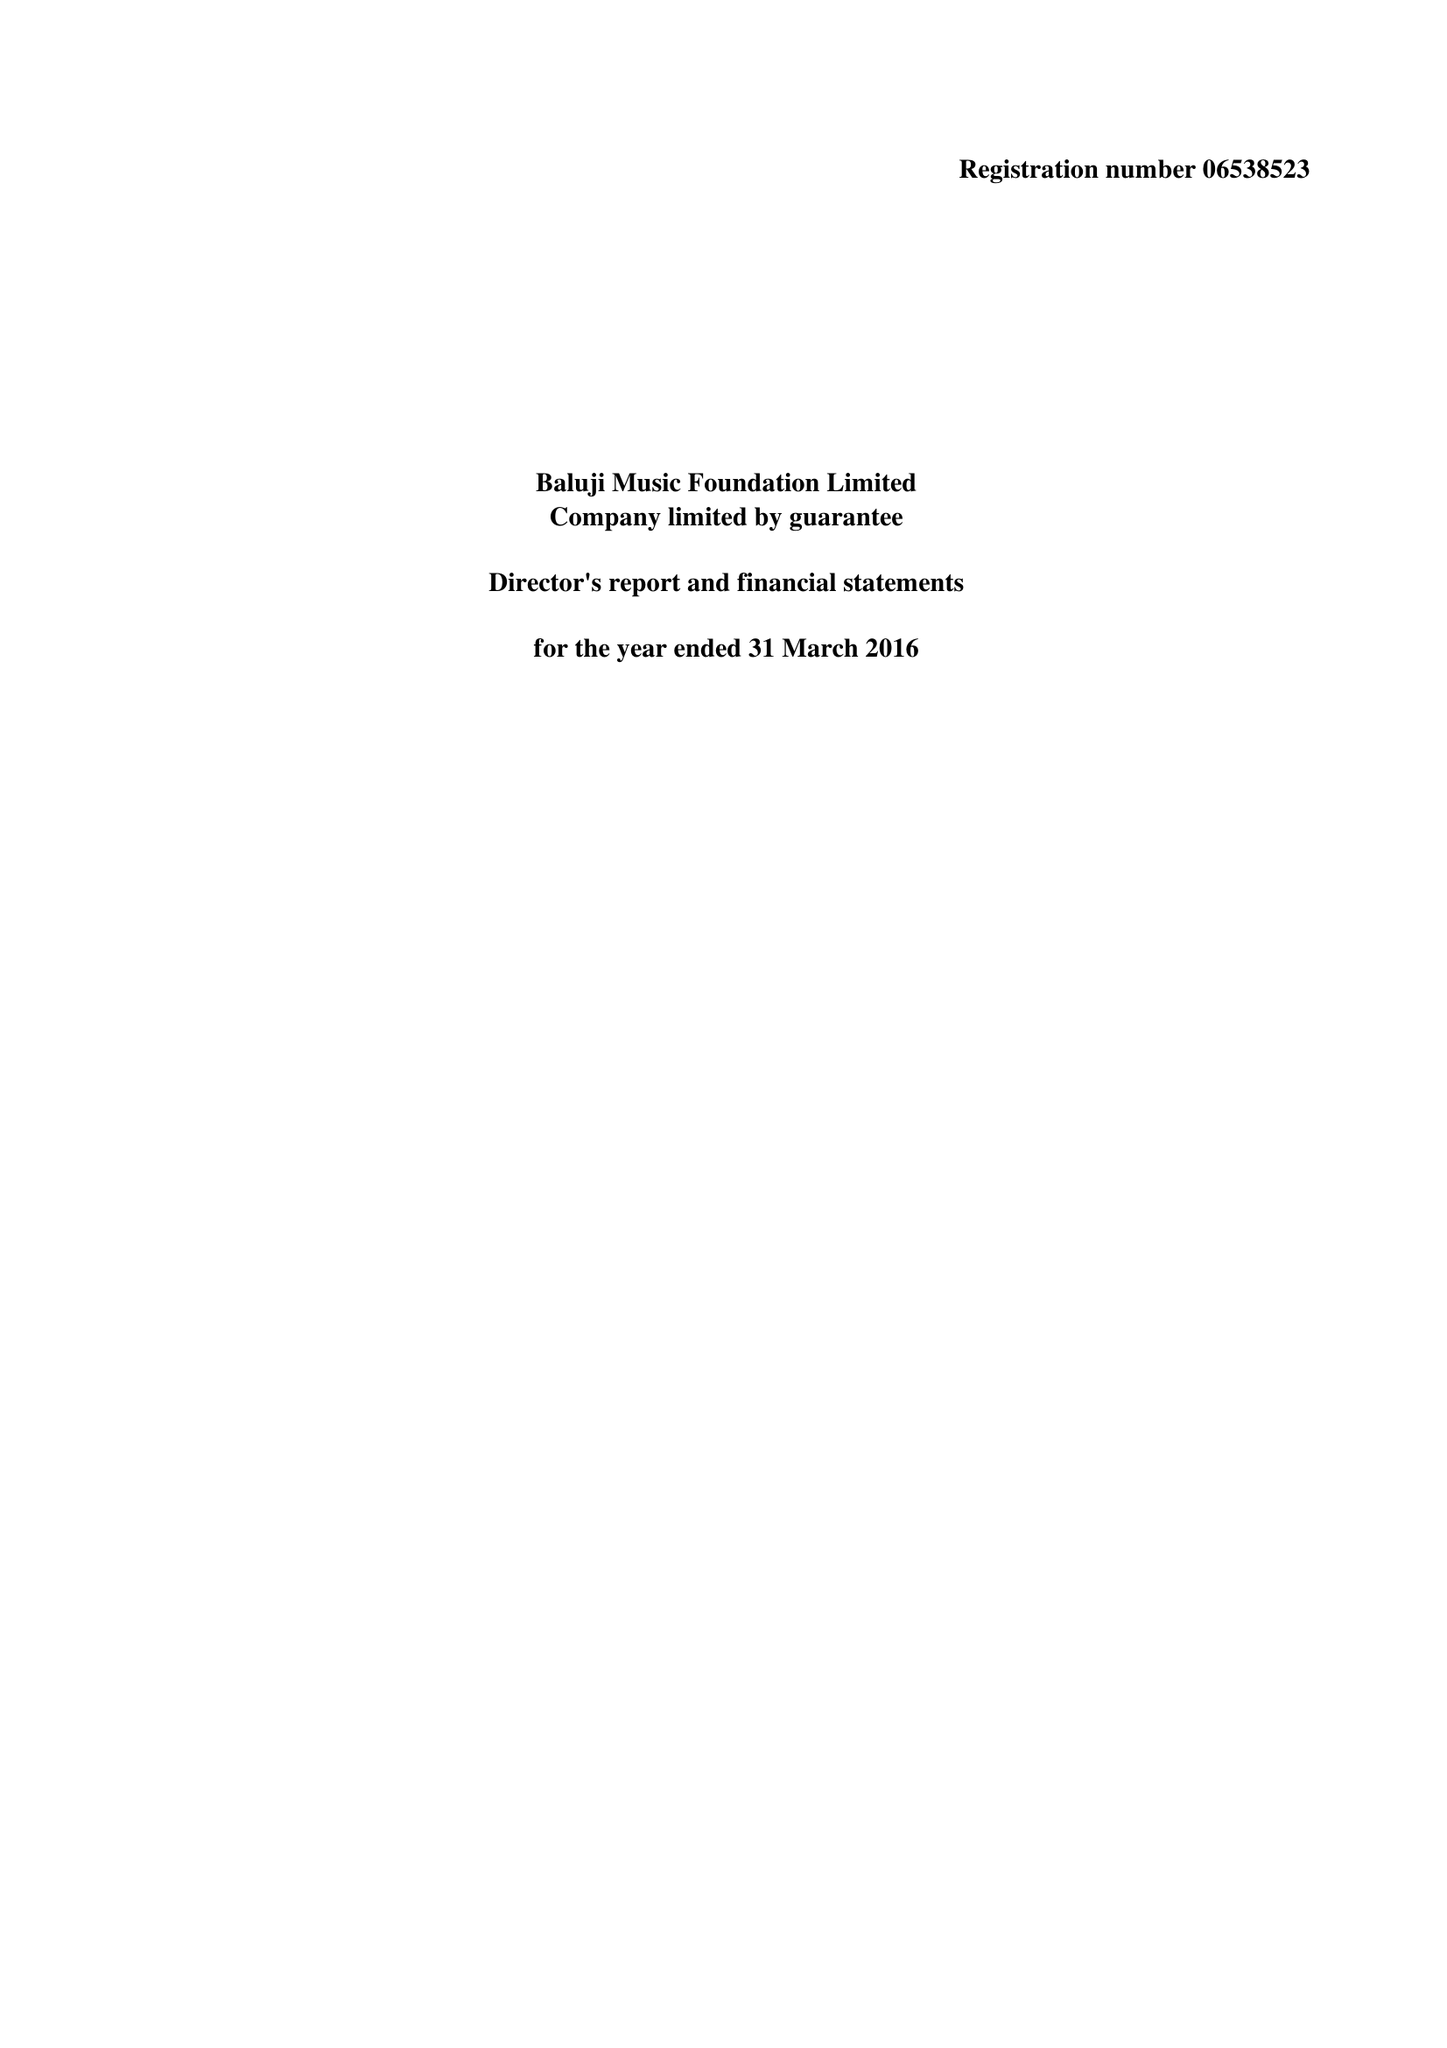What is the value for the address__post_town?
Answer the question using a single word or phrase. LONDON 